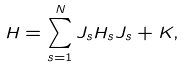<formula> <loc_0><loc_0><loc_500><loc_500>H = \sum _ { s = 1 } ^ { N } J _ { s } H _ { s } J _ { s } + K ,</formula> 